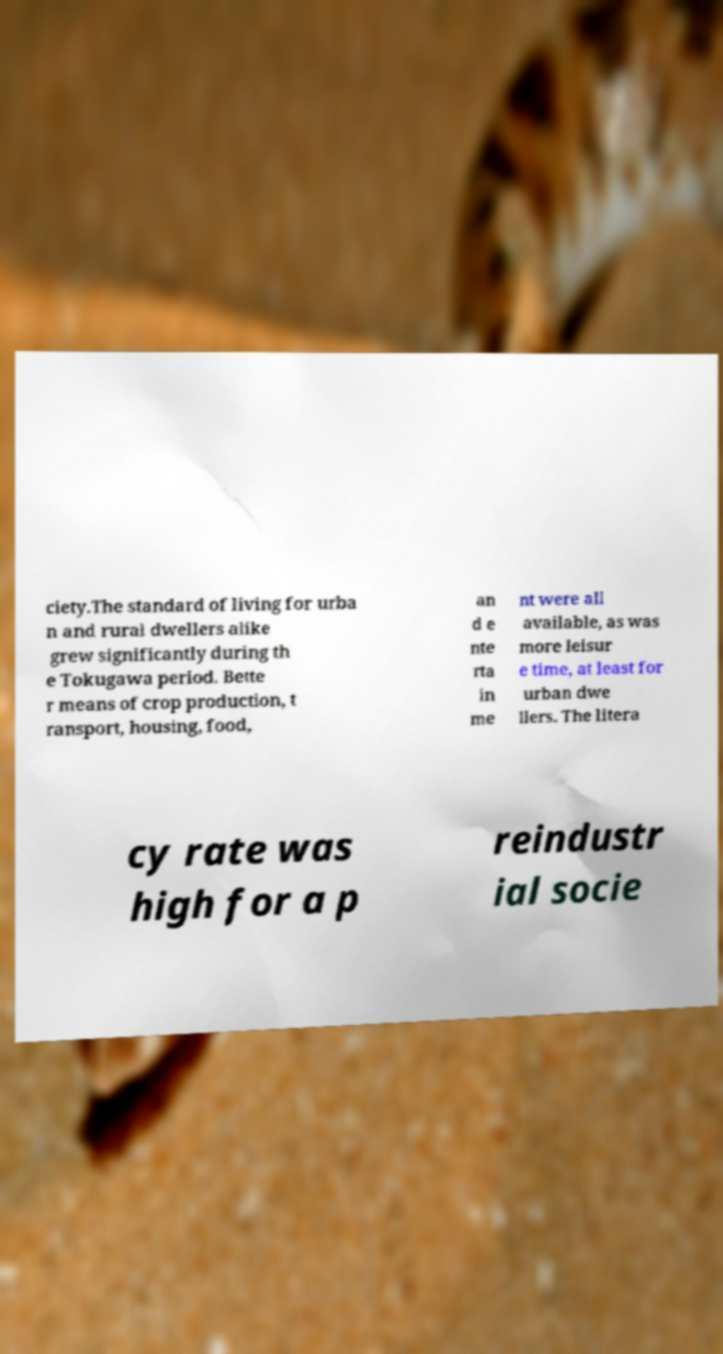Could you extract and type out the text from this image? ciety.The standard of living for urba n and rural dwellers alike grew significantly during th e Tokugawa period. Bette r means of crop production, t ransport, housing, food, an d e nte rta in me nt were all available, as was more leisur e time, at least for urban dwe llers. The litera cy rate was high for a p reindustr ial socie 